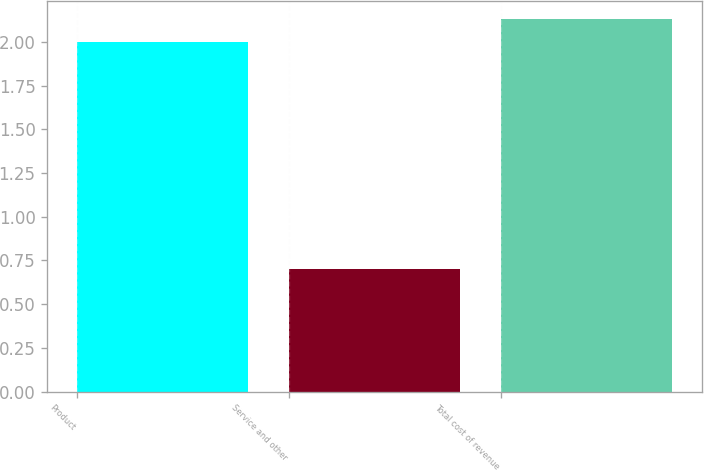Convert chart to OTSL. <chart><loc_0><loc_0><loc_500><loc_500><bar_chart><fcel>Product<fcel>Service and other<fcel>Total cost of revenue<nl><fcel>2<fcel>0.7<fcel>2.13<nl></chart> 